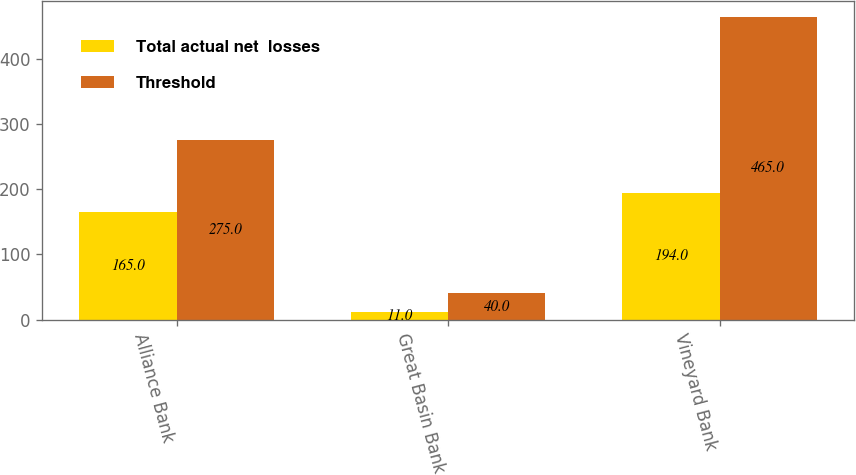Convert chart to OTSL. <chart><loc_0><loc_0><loc_500><loc_500><stacked_bar_chart><ecel><fcel>Alliance Bank<fcel>Great Basin Bank<fcel>Vineyard Bank<nl><fcel>Total actual net  losses<fcel>165<fcel>11<fcel>194<nl><fcel>Threshold<fcel>275<fcel>40<fcel>465<nl></chart> 